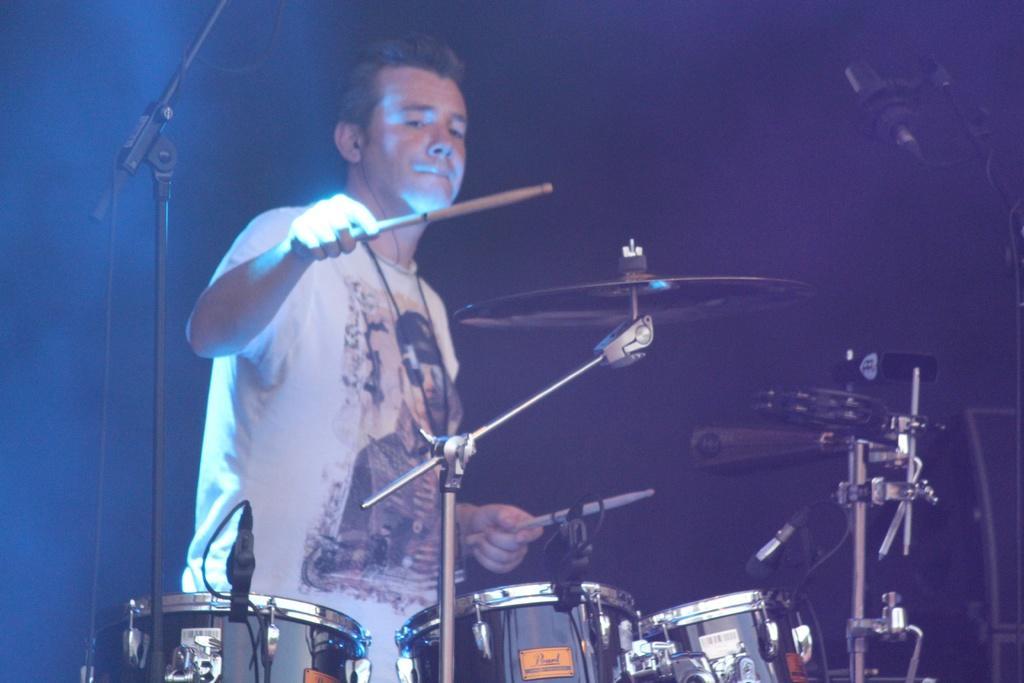Could you give a brief overview of what you see in this image? In the image there is a man in white t-shirt playing drum, this seems to be a concert. 